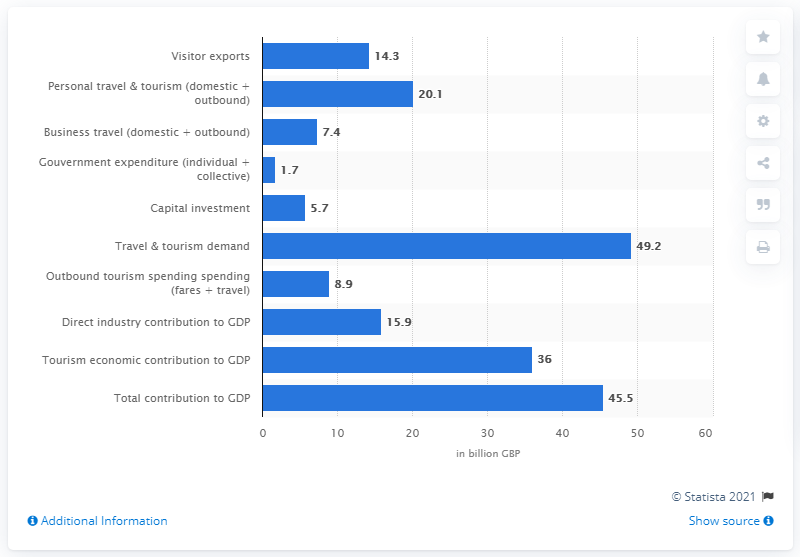Indicate a few pertinent items in this graphic. In 2013, London tourism contributed significantly to the UK's Gross Domestic Product, amounting to approximately 36%. 